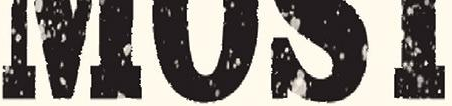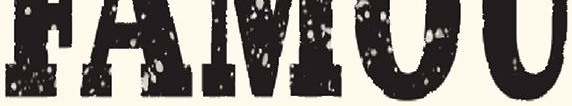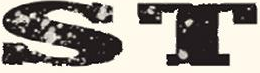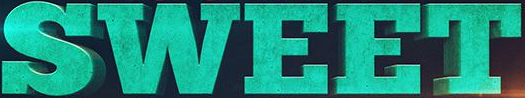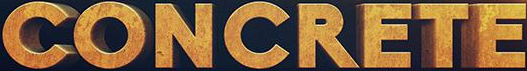Read the text content from these images in order, separated by a semicolon. ####; #####; ST; SWEET; CONCRETE 